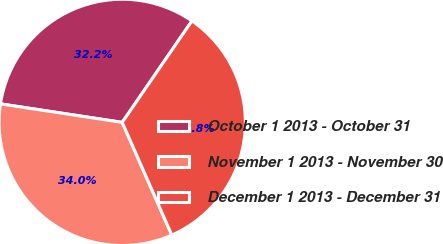Convert chart. <chart><loc_0><loc_0><loc_500><loc_500><pie_chart><fcel>October 1 2013 - October 31<fcel>November 1 2013 - November 30<fcel>December 1 2013 - December 31<nl><fcel>32.18%<fcel>34.0%<fcel>33.82%<nl></chart> 